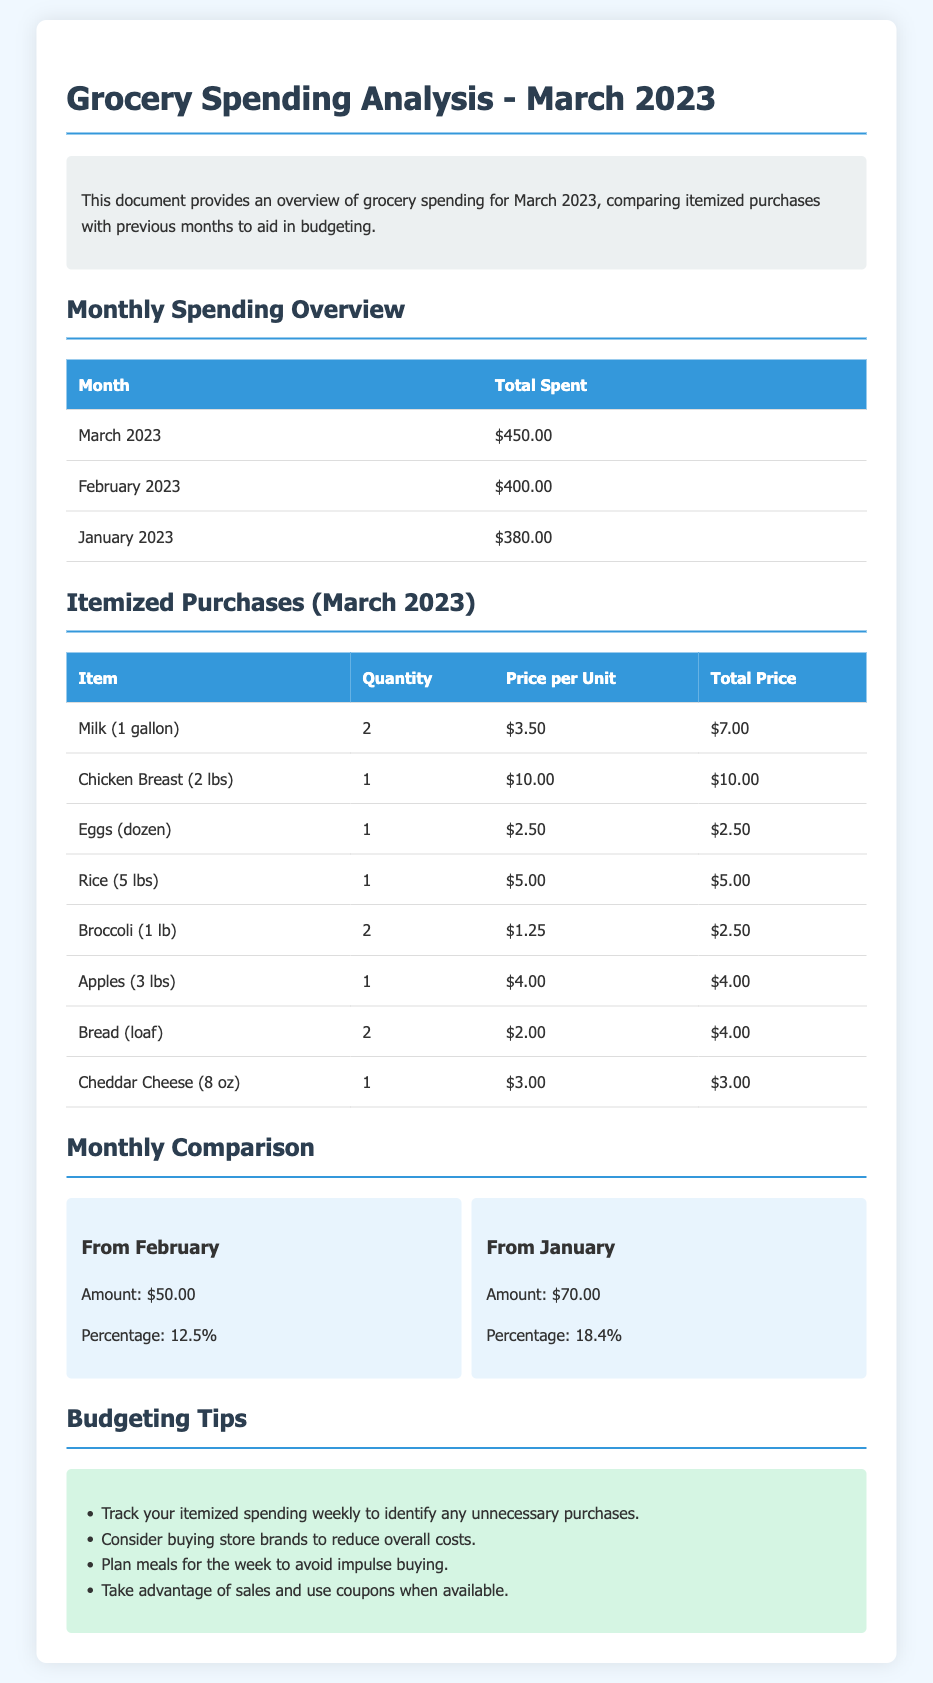What was the total amount spent in March 2023? The total amount spent in March 2023 is provided in the monthly spending overview section of the document.
Answer: $450.00 What was the total spent in February 2023? The total spent in February 2023 can be found in the same table as the March 2023 total.
Answer: $400.00 How much did the groceries cost compared to January 2023? This question involves comparing the March 2023 spending with January 2023 spending, found in the monthly comparison section.
Answer: $70.00 What percentage did grocery spending increase from February to March? The percentage increase is calculated and stated in the monthly comparison section, specifically relating to February.
Answer: 12.5% Which item was bought the most in terms of quantity in March 2023? The item with the highest quantity can be identified from the itemized purchases table, focusing on the quantity column.
Answer: Milk (1 gallon) What was the price per unit for chicken breast? The price per unit for chicken breast is specified in the itemized purchases table.
Answer: $10.00 Which month had the lowest total grocery spending? Comparing the totals in the monthly spending overview allows for identifying the month with the lowest spending.
Answer: January 2023 What is one budgeting tip provided in the document? The list of budgeting tips provides several options; any one of them can be quoted to answer this question succinctly.
Answer: Track your itemized spending weekly to identify any unnecessary purchases 